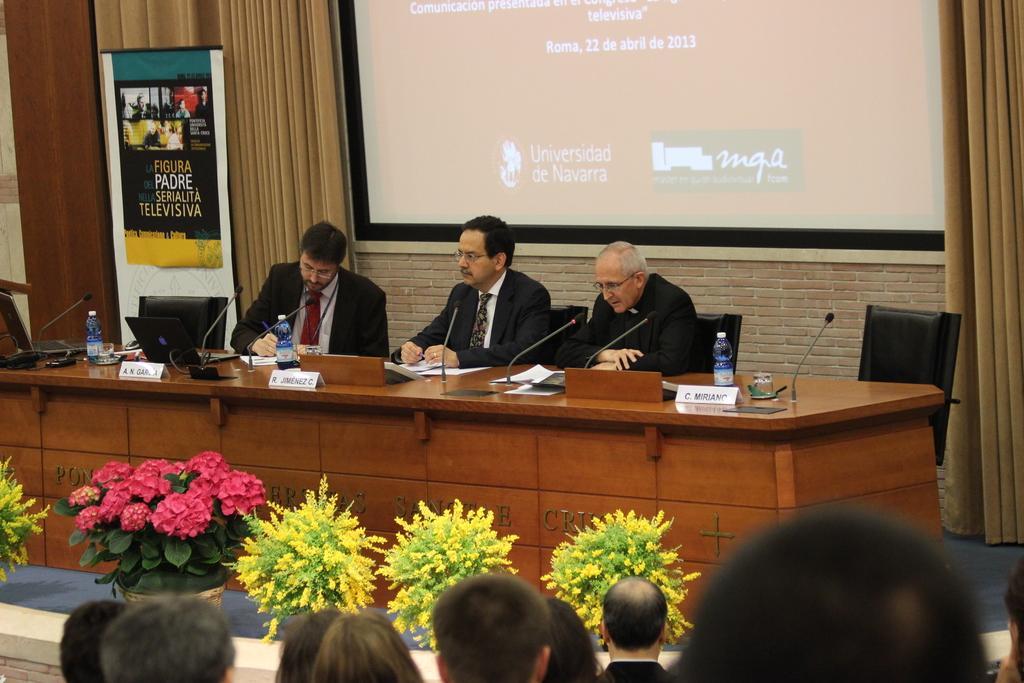Describe this image in one or two sentences. In this picture I can see few persons at the bottom, there are flowers and plants in the middle. In the background I can see few men are sitting on the chairs and there is a projector screen, on the left side I can see the laptops and few water bottles on the table, there is a banner. 